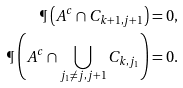<formula> <loc_0><loc_0><loc_500><loc_500>\P \left ( A ^ { c } \cap C _ { k + 1 , j + 1 } \right ) & = 0 , \\ \P \left ( A ^ { c } \cap \bigcup _ { j _ { 1 } \ne j , j + 1 } C _ { k , j _ { 1 } } \right ) & = 0 .</formula> 